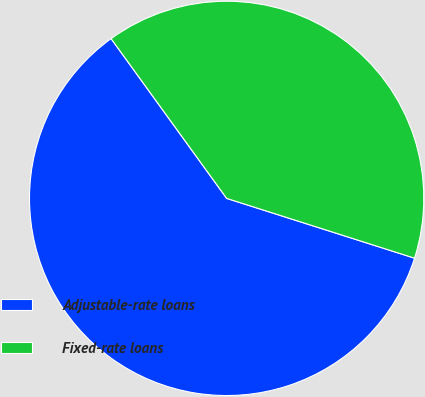Convert chart to OTSL. <chart><loc_0><loc_0><loc_500><loc_500><pie_chart><fcel>Adjustable-rate loans<fcel>Fixed-rate loans<nl><fcel>60.13%<fcel>39.87%<nl></chart> 